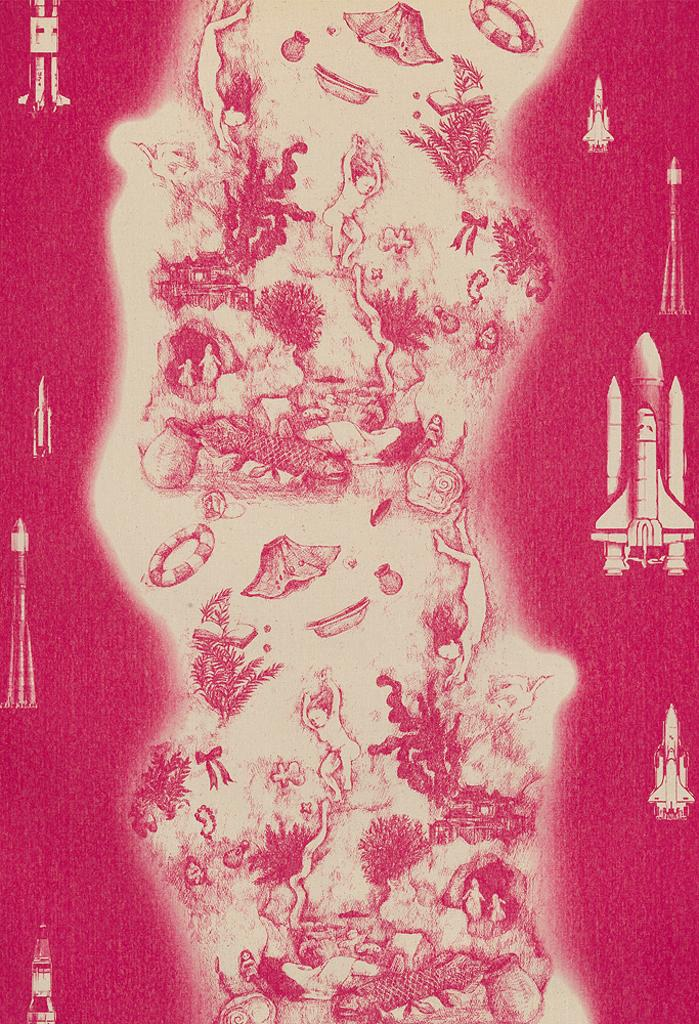What type of vehicles are present in the image? There are rockets in the image. What type of living organisms can be seen in the image? There are plants and people in the image. What else can be seen in the image besides the rockets, plants, and people? There are objects in the image. What type of money is being used to purchase the fowl in the image? There is no money or fowl present in the image. 